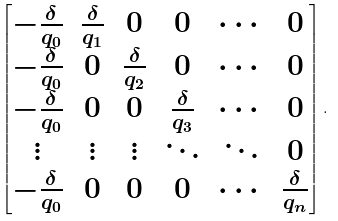Convert formula to latex. <formula><loc_0><loc_0><loc_500><loc_500>\begin{bmatrix} - \frac { \delta } { q _ { 0 } } & \frac { \delta } { q _ { 1 } } & 0 & 0 & \cdots & 0 \\ - \frac { \delta } { q _ { 0 } } & 0 & \frac { \delta } { q _ { 2 } } & 0 & \cdots & 0 \\ - \frac { \delta } { q _ { 0 } } & 0 & 0 & \frac { \delta } { q _ { 3 } } & \cdots & 0 \\ \vdots & \vdots & \vdots & \ddots & \ddots & 0 \\ - \frac { \delta } { q _ { 0 } } & 0 & 0 & 0 & \cdots & \frac { \delta } { q _ { n } } \end{bmatrix} .</formula> 